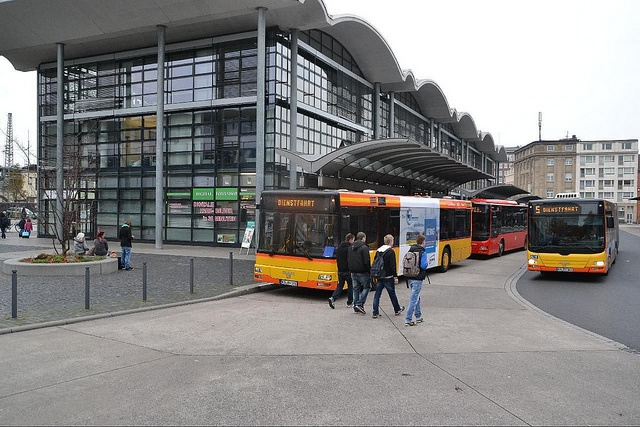Describe the objects in this image and their specific colors. I can see bus in darkgray, black, gray, and orange tones, bus in darkgray, black, gray, and orange tones, bus in darkgray, black, brown, and gray tones, people in darkgray, black, and gray tones, and people in darkgray, black, and gray tones in this image. 